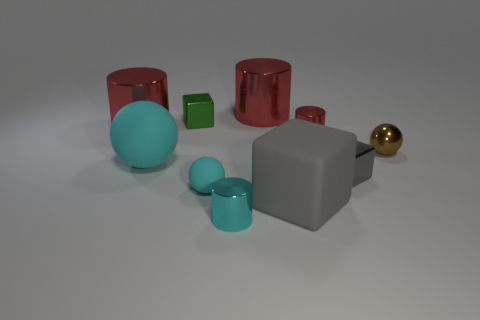There is a metallic cube in front of the big ball; is it the same color as the big cube?
Provide a succinct answer. Yes. There is another matte object that is the same shape as the tiny gray thing; what size is it?
Offer a very short reply. Large. Is the color of the big rubber ball the same as the large metal thing that is to the left of the big cyan matte sphere?
Offer a terse response. No. What is the material of the block that is both left of the tiny red thing and in front of the tiny red metal thing?
Make the answer very short. Rubber. What size is the thing that is the same color as the rubber block?
Offer a very short reply. Small. Does the red metallic thing that is to the right of the big gray cube have the same shape as the large rubber object that is on the left side of the green shiny thing?
Offer a terse response. No. Is there a big sphere?
Offer a terse response. Yes. The big thing that is the same shape as the tiny gray shiny thing is what color?
Your answer should be compact. Gray. The matte sphere that is the same size as the gray matte object is what color?
Make the answer very short. Cyan. Are the tiny cyan cylinder and the big gray block made of the same material?
Make the answer very short. No. 